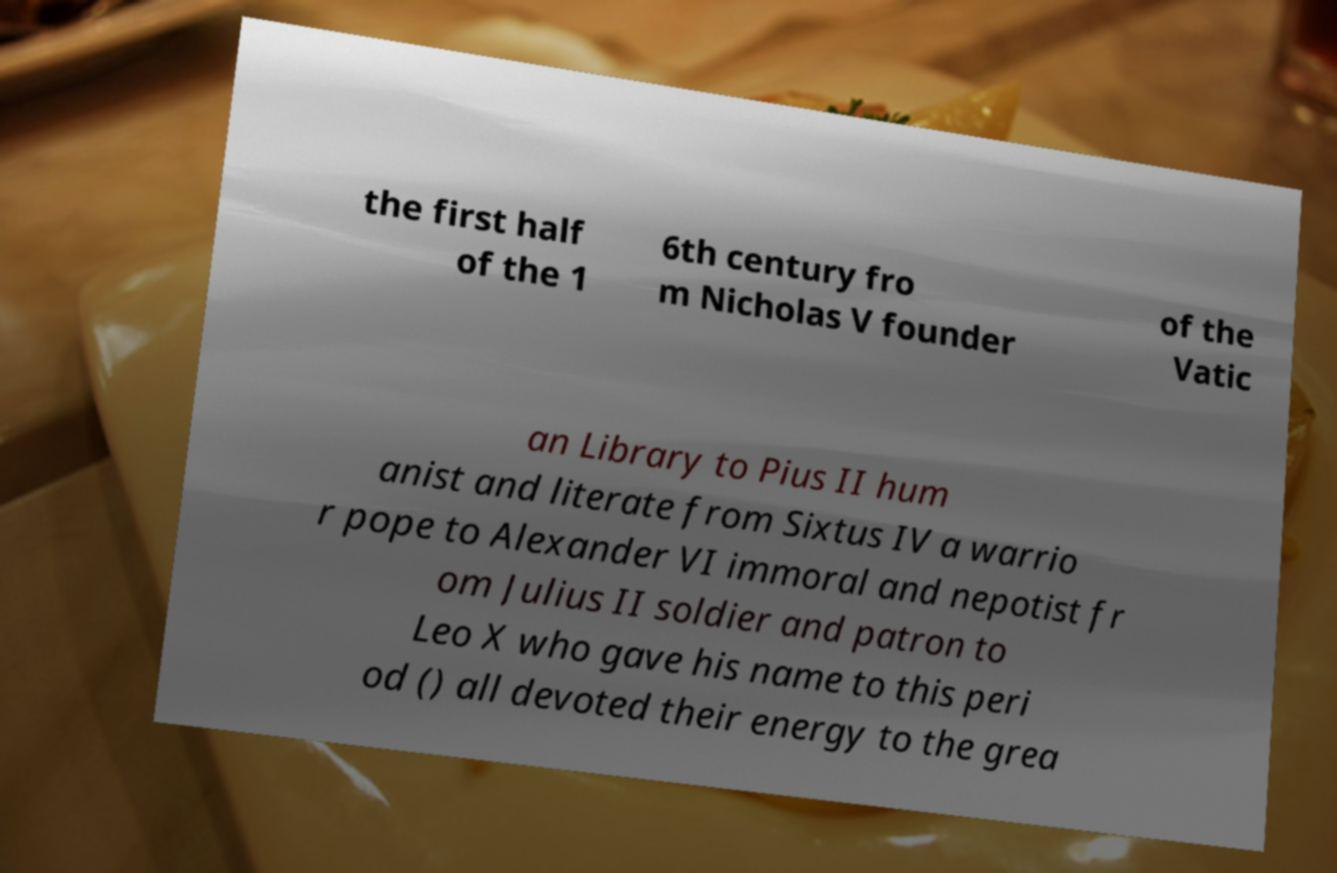Please identify and transcribe the text found in this image. the first half of the 1 6th century fro m Nicholas V founder of the Vatic an Library to Pius II hum anist and literate from Sixtus IV a warrio r pope to Alexander VI immoral and nepotist fr om Julius II soldier and patron to Leo X who gave his name to this peri od () all devoted their energy to the grea 